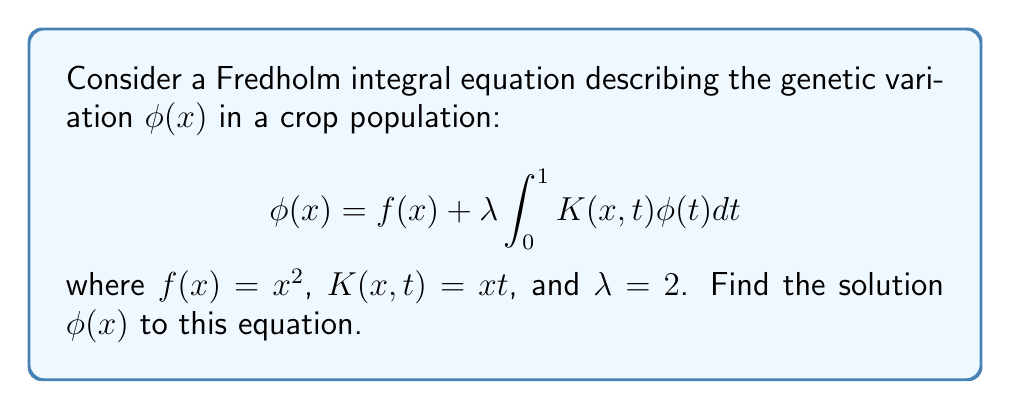Can you solve this math problem? To solve this Fredholm integral equation, we'll follow these steps:

1) First, assume that the solution has the form $\phi(x) = ax^2 + bx$, where $a$ and $b$ are constants to be determined.

2) Substitute this into the right-hand side of the equation:

   $$f(x) + \lambda \int_0^1 K(x,t)\phi(t)dt = x^2 + 2 \int_0^1 xt(at^2 + bt)dt$$

3) Evaluate the integral:

   $$x^2 + 2x \int_0^1 (at^3 + bt^2)dt = x^2 + 2x \left[\frac{a}{4}t^4 + \frac{b}{3}t^3\right]_0^1$$
   
   $$= x^2 + 2x \left(\frac{a}{4} + \frac{b}{3}\right)$$

4) This should equal our assumed solution $ax^2 + bx$. Comparing coefficients:

   For $x^2$: $a = 1$
   For $x$: $b = 2(\frac{1}{4} + \frac{b}{3})$

5) From the second equation:

   $b = \frac{1}{2} + \frac{2b}{3}$
   $3b = \frac{3}{2} + 2b$
   $b = \frac{3}{2}$

6) Therefore, the solution is:

   $$\phi(x) = x^2 + \frac{3}{2}x$$

7) Verify by substituting back into the original equation:

   $$x^2 + \frac{3}{2}x = x^2 + 2 \int_0^1 xt(t^2 + \frac{3}{2}t)dt$$
   
   $$= x^2 + 2x \left[\frac{1}{4}t^4 + \frac{1}{2}t^3\right]_0^1 = x^2 + 2x(\frac{1}{4} + \frac{1}{2}) = x^2 + \frac{3}{2}x$$

This confirms our solution.
Answer: $\phi(x) = x^2 + \frac{3}{2}x$ 